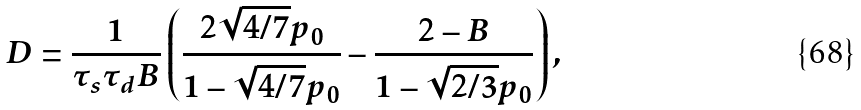Convert formula to latex. <formula><loc_0><loc_0><loc_500><loc_500>D = \frac { 1 } { \tau _ { s } \tau _ { d } B } \left ( \frac { 2 \sqrt { 4 / 7 } p _ { 0 } } { 1 - \sqrt { 4 / 7 } p _ { 0 } } - \frac { 2 - B } { 1 - \sqrt { 2 / 3 } p _ { 0 } } \right ) ,</formula> 